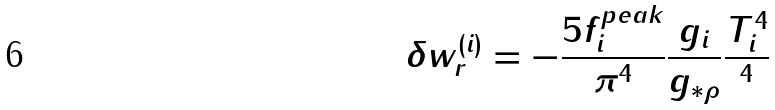Convert formula to latex. <formula><loc_0><loc_0><loc_500><loc_500>\delta w _ { r } ^ { ( i ) } = - \frac { 5 f _ { i } ^ { p e a k } } { \pi ^ { 4 } } \frac { g _ { i } } { g _ { \ast \rho } } \frac { T _ { i } ^ { 4 } } { ^ { 4 } }</formula> 